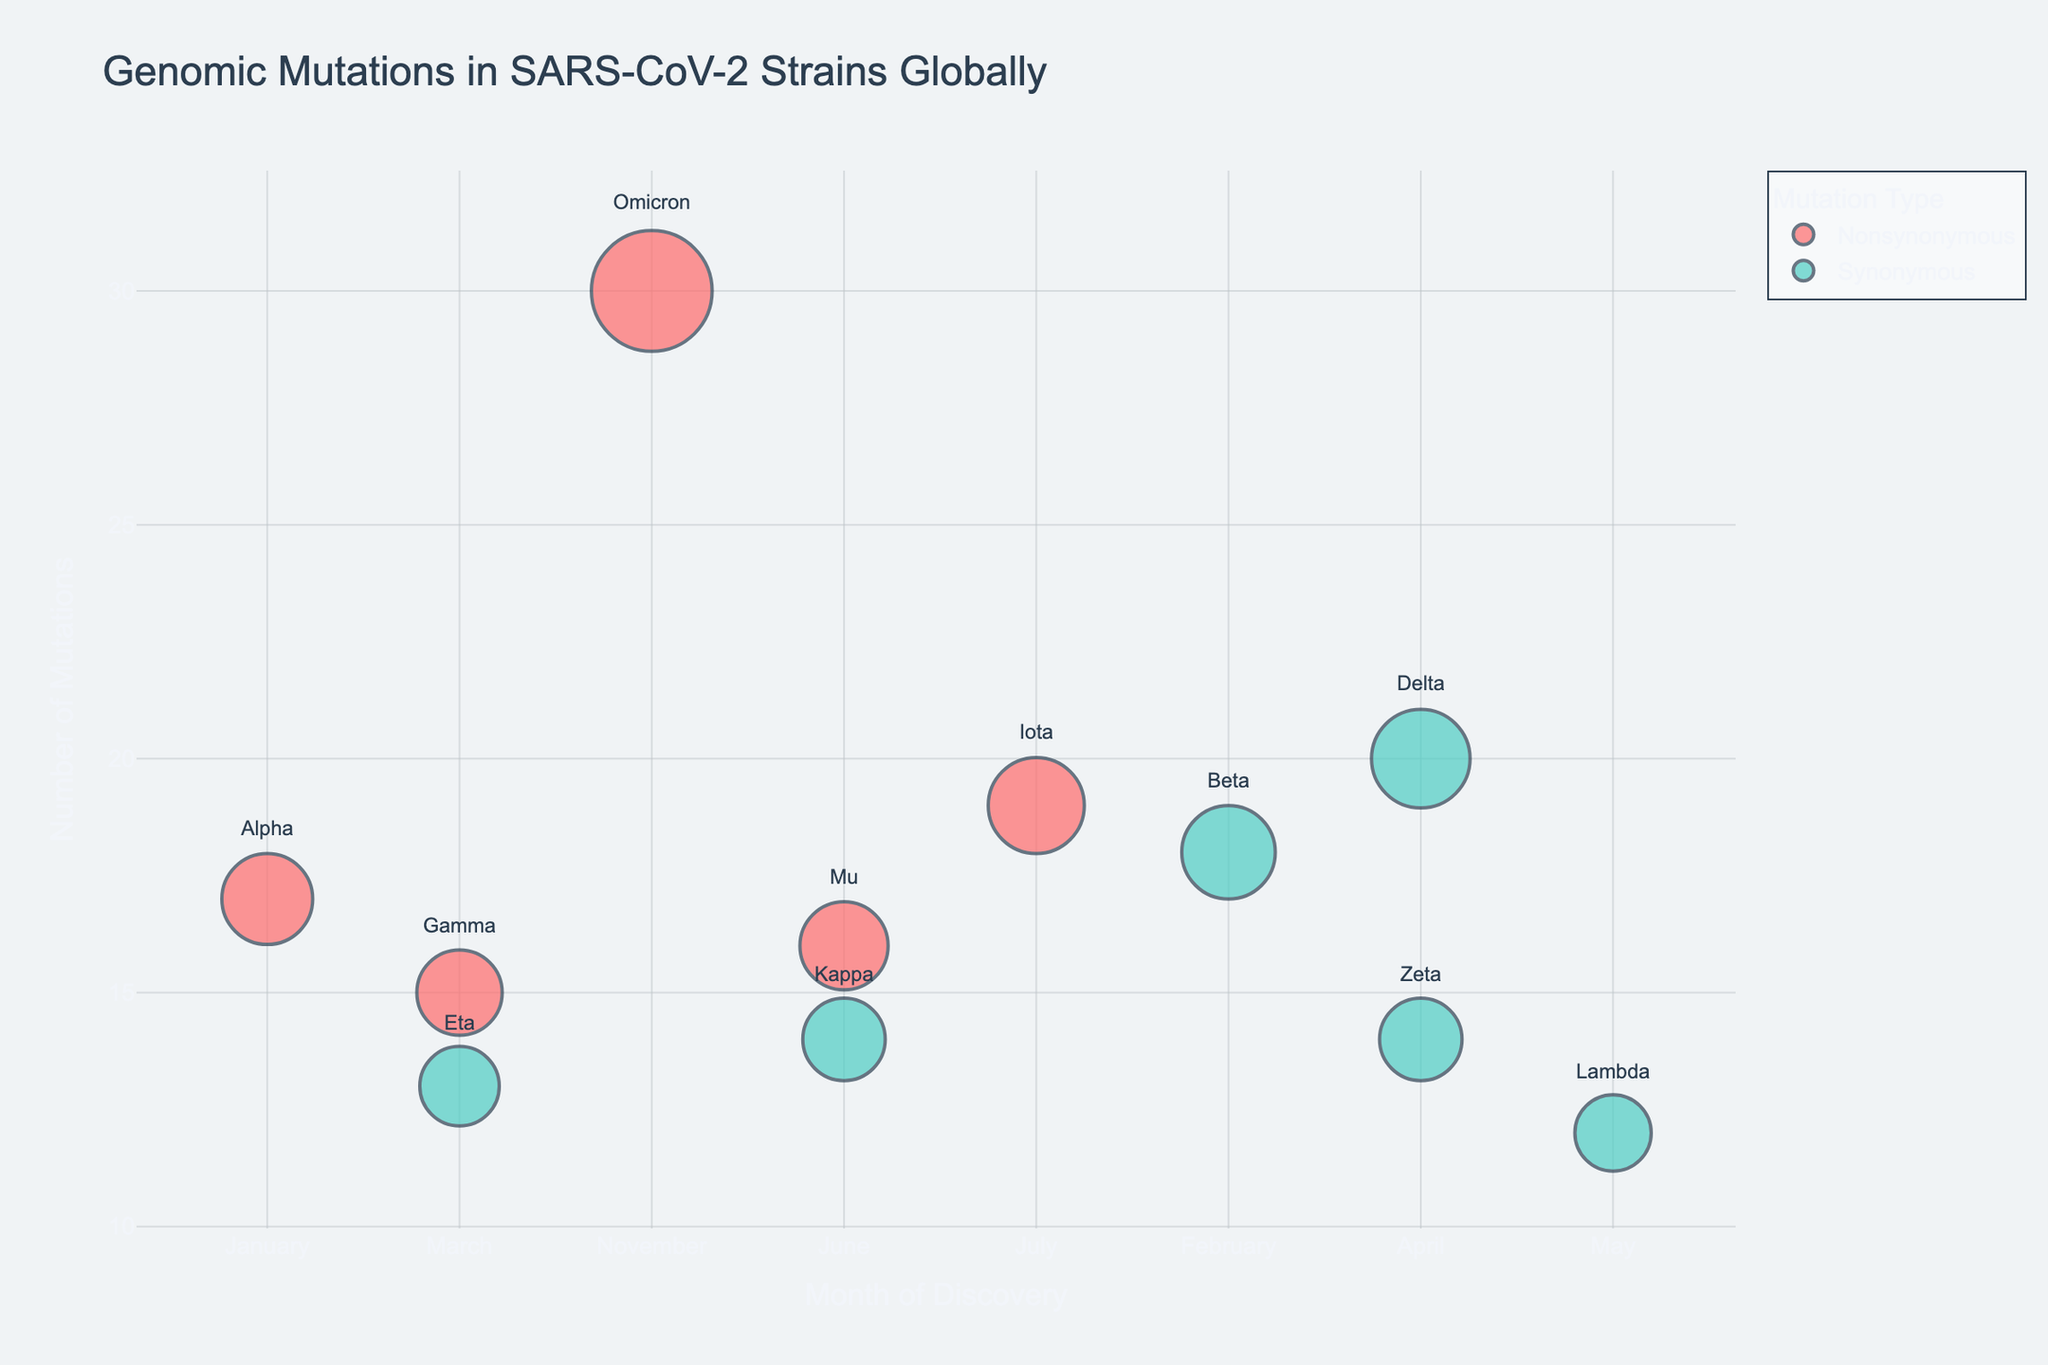what is the title of the figure? The title of the figure is shown at the top of the chart. It reads "Genomic Mutations in SARS-CoV-2 Strains Globally".
Answer: Genomic Mutations in SARS-CoV-2 Strains Globally How many nonsynonymous mutation strains are depicted in April? By looking at the chart and checking the number of bubbles color-coded for "Nonsynonymous" in the month of April, it is clear there is only one: Delta.
Answer: 1 Which strain has the highest number of mutations? To answer this, look for the largest bubble on the chart and check its label. The largest bubble represents the Omicron strain, which has 30 mutations.
Answer: Omicron What is the difference in the number of mutations between the strain with the highest mutations and the strain with the lowest mutations? The Omicron strain has 30 mutations (highest), and the Lambda strain has 12 mutations (lowest). The difference is 30 - 12 = 18 mutations.
Answer: 18 Which month saw the highest variety of strains reported? By counting the number of bubbles above each month, April shows two bubbles: Delta and Zeta, indicating this month has the highest variety.
Answer: April Which country has multiple strains reported? Look for bubbles with associated countries and check for repetition. Brazil has two strains: Gamma and Zeta.
Answer: Brazil Are there more synonymous or nonsynonymous strains in total? Count the number of bubbles color-coded for "Synonymous" and "Nonsynonymous." There are 5 synonymous and 6 nonsynonymous strains.
Answer: Nonsynonymous In which month was the Gamma strain reported, and how many mutations does it have? Identify the bubble labeled "Gamma" and note the x-axis position for the month and the bubble size for the number of mutations. Gamma is reported in March with 15 mutations.
Answer: March, 15 How many strains have exactly 14 mutations? Look for bubbles with a size corresponding to 14 mutations. The chart shows two such bubbles: Zeta and Kappa.
Answer: 2 